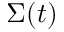<formula> <loc_0><loc_0><loc_500><loc_500>\Sigma ( t )</formula> 